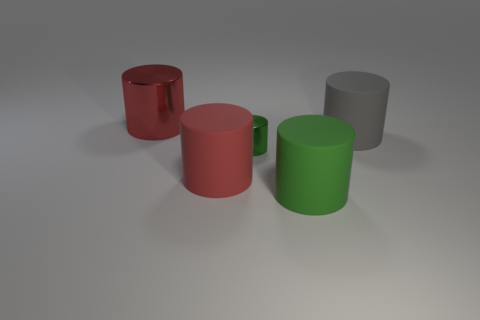The small object has what color?
Offer a terse response. Green. There is a tiny shiny thing; are there any green cylinders on the right side of it?
Provide a short and direct response. Yes. Is the color of the tiny metallic thing the same as the big metallic thing?
Your response must be concise. No. How many large metal things are the same color as the big metallic cylinder?
Provide a succinct answer. 0. What size is the red cylinder on the right side of the large red cylinder that is behind the gray rubber cylinder?
Make the answer very short. Large. The tiny green shiny thing is what shape?
Provide a succinct answer. Cylinder. What is the red cylinder that is behind the small thing made of?
Provide a succinct answer. Metal. The cylinder behind the rubber object on the right side of the large green object in front of the small green metallic thing is what color?
Make the answer very short. Red. How many matte objects are either big cylinders or large cyan cylinders?
Your answer should be compact. 3. What material is the large green cylinder that is in front of the tiny green cylinder that is in front of the gray cylinder?
Provide a succinct answer. Rubber. 